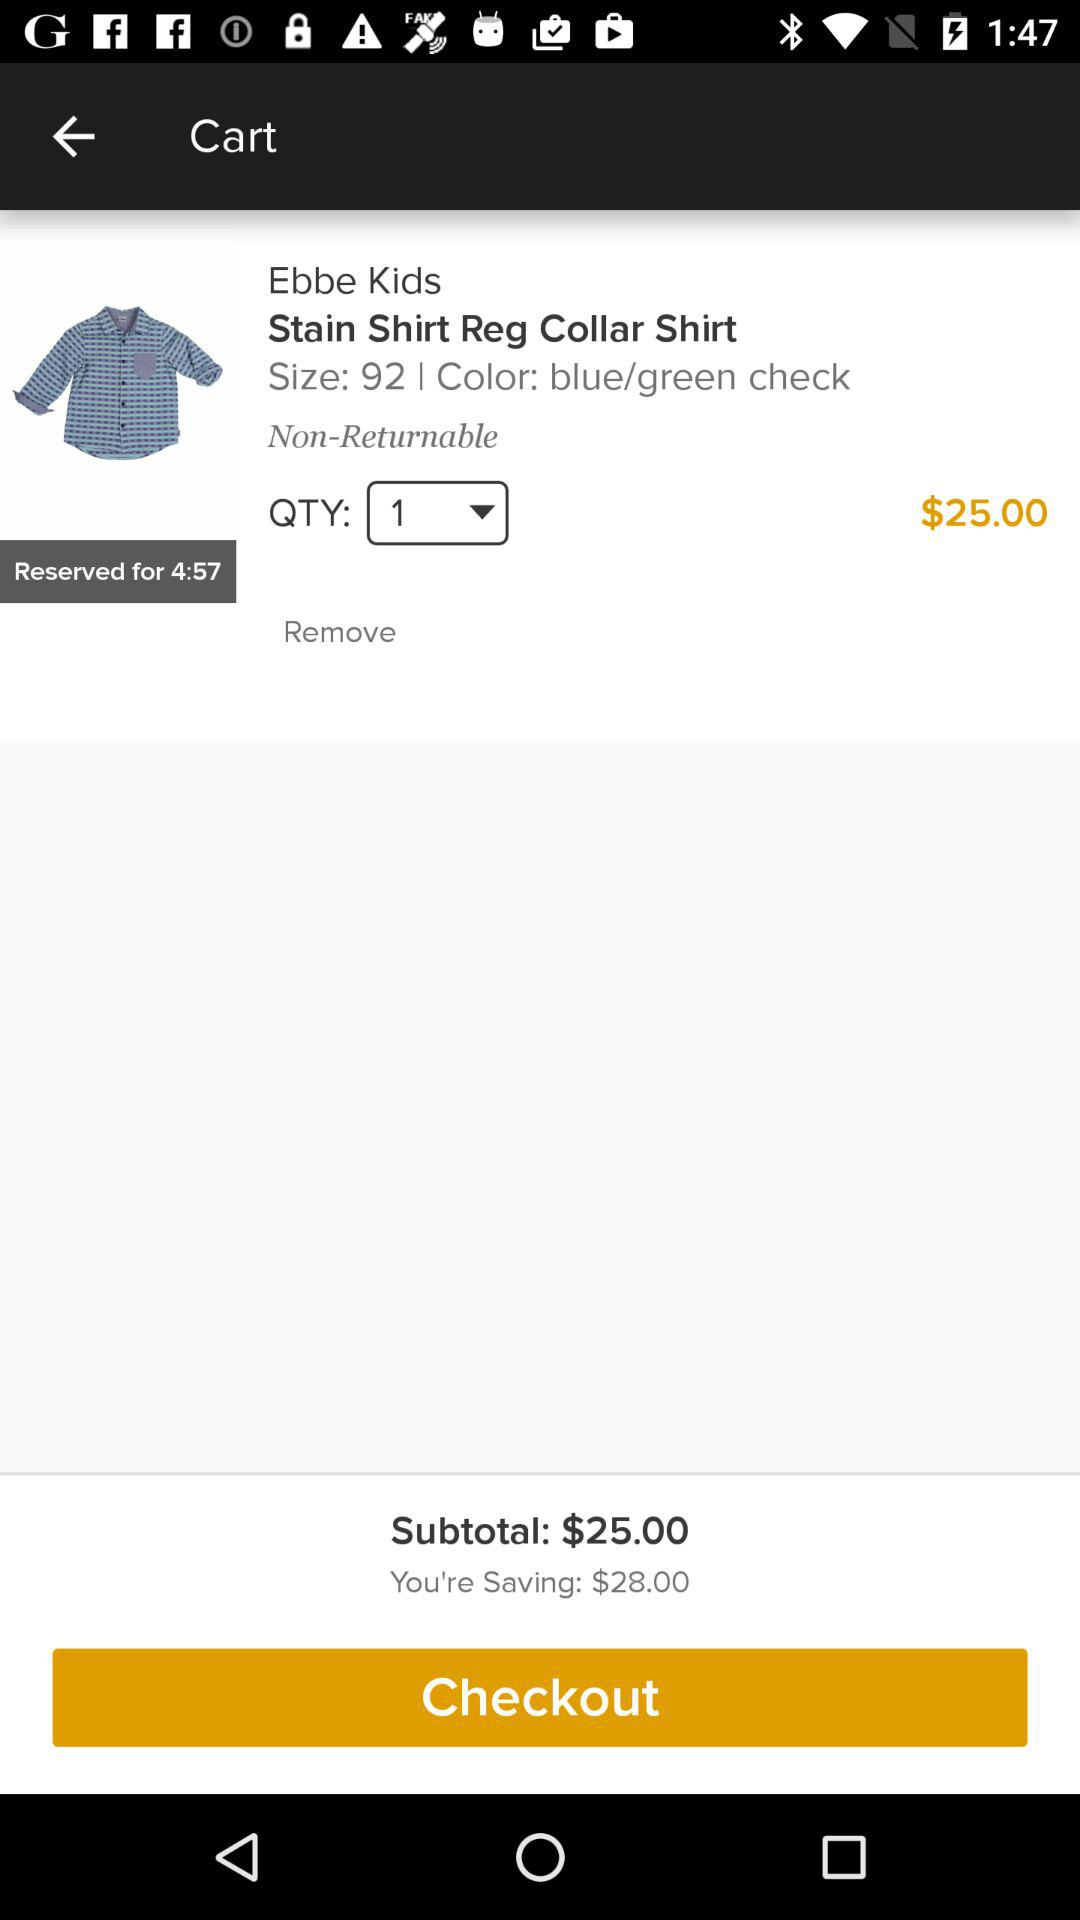What's the savings amount? The savings amount is $28. 